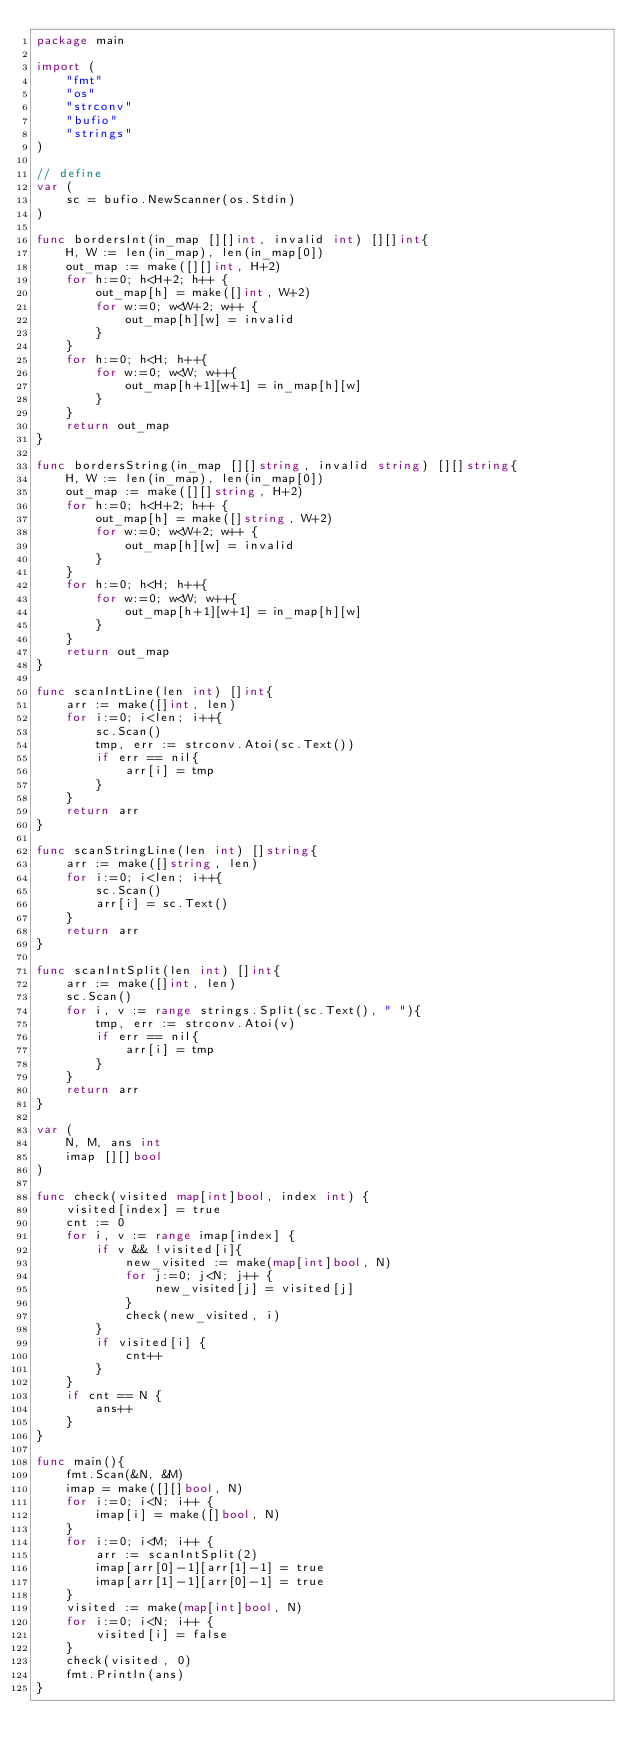<code> <loc_0><loc_0><loc_500><loc_500><_Go_>package main

import (
	"fmt"
	"os"
	"strconv"
	"bufio"
	"strings"
)

// define
var (
	sc = bufio.NewScanner(os.Stdin)
)

func bordersInt(in_map [][]int, invalid int) [][]int{
	H, W := len(in_map), len(in_map[0])
	out_map := make([][]int, H+2)
	for h:=0; h<H+2; h++ {
		out_map[h] = make([]int, W+2)
		for w:=0; w<W+2; w++ {
			out_map[h][w] = invalid
		}
	}
	for h:=0; h<H; h++{
		for w:=0; w<W; w++{
			out_map[h+1][w+1] = in_map[h][w] 
		}
	}
	return out_map
}

func bordersString(in_map [][]string, invalid string) [][]string{
	H, W := len(in_map), len(in_map[0])
	out_map := make([][]string, H+2)
	for h:=0; h<H+2; h++ {
		out_map[h] = make([]string, W+2)
		for w:=0; w<W+2; w++ {
			out_map[h][w] = invalid
		}
	}
	for h:=0; h<H; h++{
		for w:=0; w<W; w++{
			out_map[h+1][w+1] = in_map[h][w] 
		}
	}
	return out_map
}

func scanIntLine(len int) []int{
	arr := make([]int, len)
	for i:=0; i<len; i++{
		sc.Scan()
		tmp, err := strconv.Atoi(sc.Text())
		if err == nil{
			arr[i] = tmp
		}
	}
	return arr
}

func scanStringLine(len int) []string{
	arr := make([]string, len)
	for i:=0; i<len; i++{
		sc.Scan()
		arr[i] = sc.Text()
	}
	return arr
}

func scanIntSplit(len int) []int{
	arr := make([]int, len)
	sc.Scan()
	for i, v := range strings.Split(sc.Text(), " "){
		tmp, err := strconv.Atoi(v)
		if err == nil{
			arr[i] = tmp
		}
	}
	return arr
}

var (
	N, M, ans int
	imap [][]bool
)

func check(visited map[int]bool, index int) {
	visited[index] = true
	cnt := 0
	for i, v := range imap[index] {
		if v && !visited[i]{
			new_visited := make(map[int]bool, N)
			for j:=0; j<N; j++ {
				new_visited[j] = visited[j]
			}
			check(new_visited, i)
		}
		if visited[i] {
			cnt++
		}
	}
	if cnt == N {
		ans++
	}
}

func main(){
	fmt.Scan(&N, &M)
	imap = make([][]bool, N)
	for i:=0; i<N; i++ {
		imap[i] = make([]bool, N)
	}
	for i:=0; i<M; i++ {
		arr := scanIntSplit(2)
		imap[arr[0]-1][arr[1]-1] = true
		imap[arr[1]-1][arr[0]-1] = true
	}
	visited := make(map[int]bool, N)
	for i:=0; i<N; i++ {
		visited[i] = false
	}
	check(visited, 0)
	fmt.Println(ans)
}</code> 